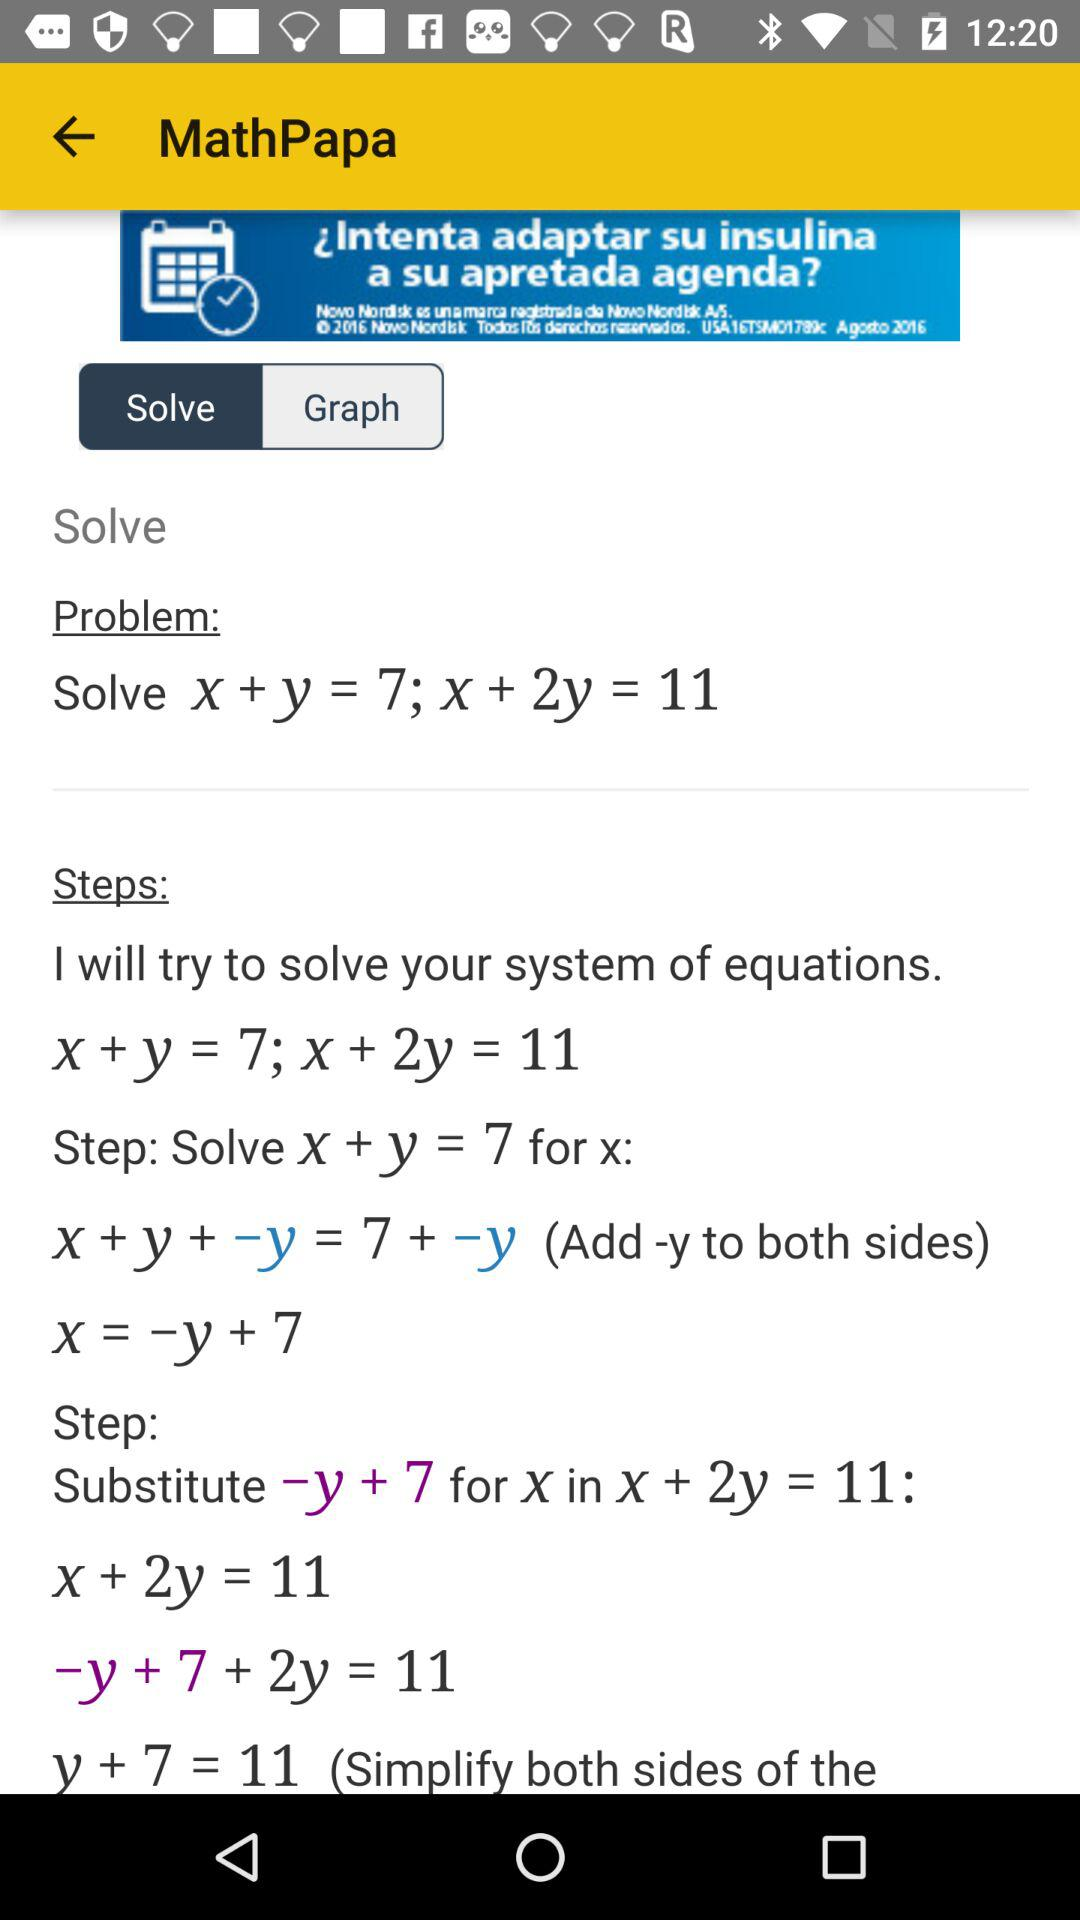How many equations are there in the problem?
Answer the question using a single word or phrase. 2 